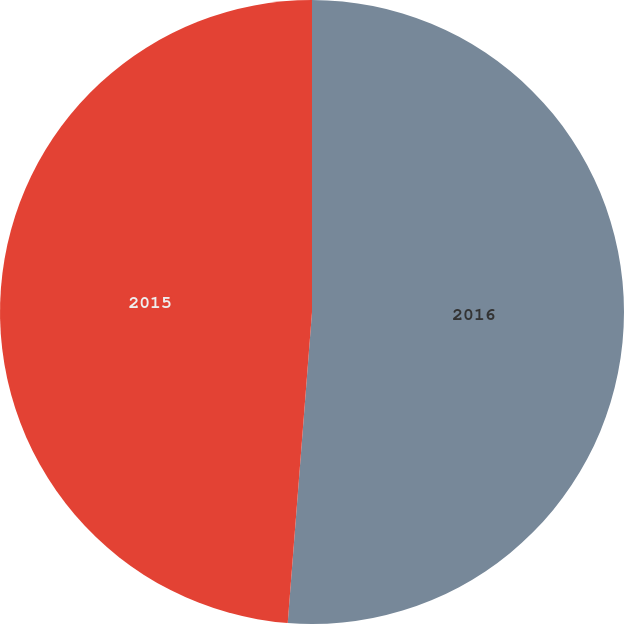<chart> <loc_0><loc_0><loc_500><loc_500><pie_chart><fcel>2016<fcel>2015<nl><fcel>51.24%<fcel>48.76%<nl></chart> 